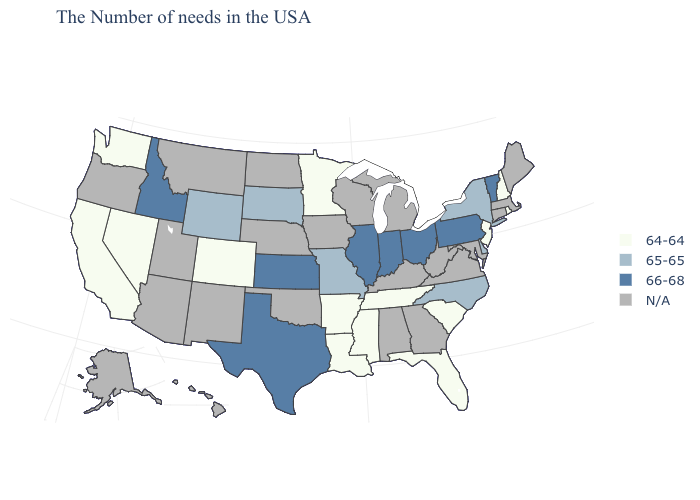Name the states that have a value in the range 65-65?
Quick response, please. New York, Delaware, North Carolina, Missouri, South Dakota, Wyoming. What is the value of Ohio?
Quick response, please. 66-68. Among the states that border Texas , which have the lowest value?
Keep it brief. Louisiana, Arkansas. Does North Carolina have the highest value in the USA?
Short answer required. No. Among the states that border Wyoming , does Colorado have the lowest value?
Give a very brief answer. Yes. What is the value of Vermont?
Short answer required. 66-68. Which states have the highest value in the USA?
Keep it brief. Vermont, Pennsylvania, Ohio, Indiana, Illinois, Kansas, Texas, Idaho. Does the first symbol in the legend represent the smallest category?
Answer briefly. Yes. Does New Jersey have the highest value in the Northeast?
Give a very brief answer. No. What is the value of New Jersey?
Answer briefly. 64-64. Name the states that have a value in the range 65-65?
Keep it brief. New York, Delaware, North Carolina, Missouri, South Dakota, Wyoming. Which states have the lowest value in the West?
Answer briefly. Colorado, Nevada, California, Washington. Name the states that have a value in the range 66-68?
Be succinct. Vermont, Pennsylvania, Ohio, Indiana, Illinois, Kansas, Texas, Idaho. Which states have the lowest value in the Northeast?
Quick response, please. Rhode Island, New Hampshire, New Jersey. 